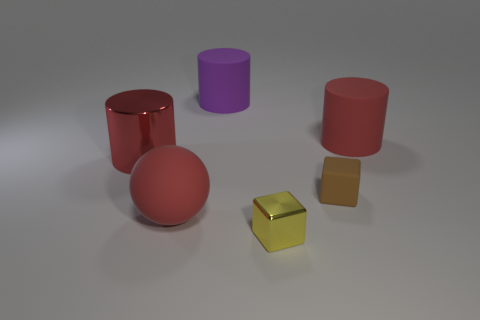Add 3 red objects. How many objects exist? 9 Subtract all cubes. How many objects are left? 4 Subtract all red rubber cylinders. Subtract all red metal cylinders. How many objects are left? 4 Add 4 small yellow metal blocks. How many small yellow metal blocks are left? 5 Add 2 yellow cubes. How many yellow cubes exist? 3 Subtract 0 cyan cylinders. How many objects are left? 6 